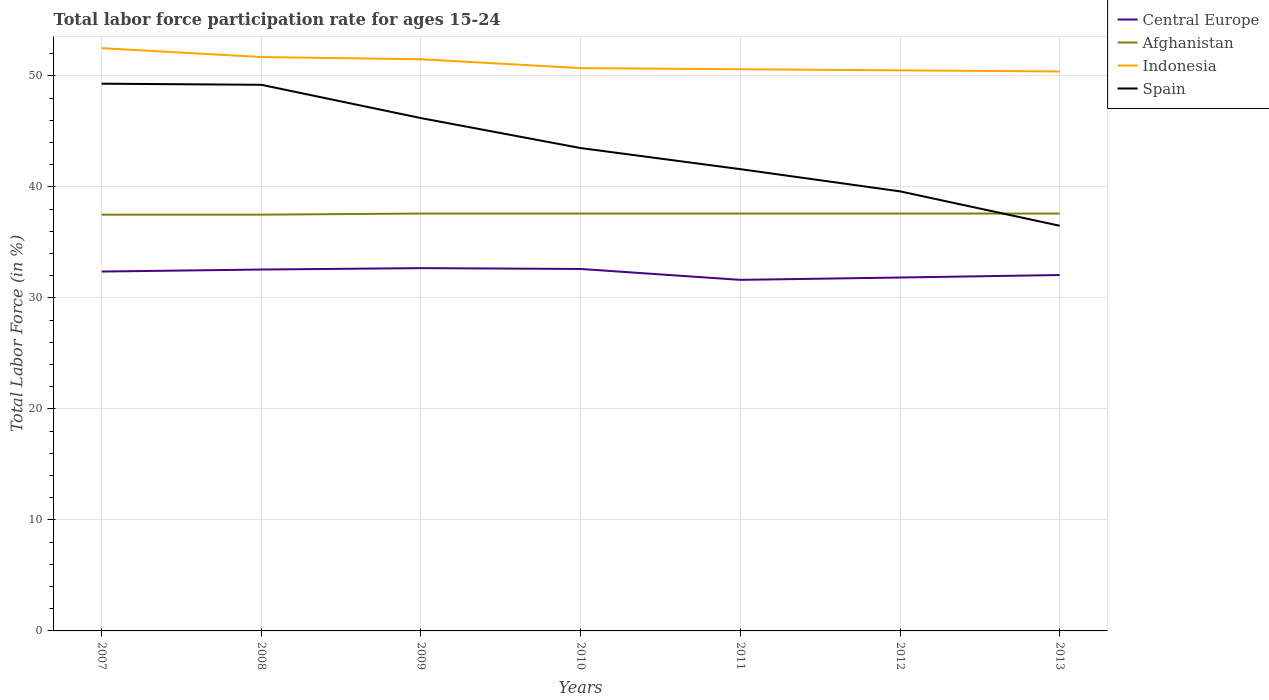How many different coloured lines are there?
Offer a terse response. 4. Does the line corresponding to Afghanistan intersect with the line corresponding to Spain?
Ensure brevity in your answer.  Yes. Is the number of lines equal to the number of legend labels?
Provide a succinct answer. Yes. Across all years, what is the maximum labor force participation rate in Afghanistan?
Offer a very short reply. 37.5. What is the total labor force participation rate in Spain in the graph?
Provide a short and direct response. 4.6. What is the difference between the highest and the second highest labor force participation rate in Afghanistan?
Ensure brevity in your answer.  0.1. What is the difference between the highest and the lowest labor force participation rate in Afghanistan?
Your answer should be very brief. 5. How many lines are there?
Offer a very short reply. 4. Where does the legend appear in the graph?
Provide a succinct answer. Top right. How are the legend labels stacked?
Offer a very short reply. Vertical. What is the title of the graph?
Offer a terse response. Total labor force participation rate for ages 15-24. Does "Antigua and Barbuda" appear as one of the legend labels in the graph?
Offer a terse response. No. What is the label or title of the X-axis?
Provide a short and direct response. Years. What is the label or title of the Y-axis?
Ensure brevity in your answer.  Total Labor Force (in %). What is the Total Labor Force (in %) of Central Europe in 2007?
Ensure brevity in your answer.  32.38. What is the Total Labor Force (in %) of Afghanistan in 2007?
Provide a succinct answer. 37.5. What is the Total Labor Force (in %) of Indonesia in 2007?
Your response must be concise. 52.5. What is the Total Labor Force (in %) of Spain in 2007?
Offer a terse response. 49.3. What is the Total Labor Force (in %) of Central Europe in 2008?
Give a very brief answer. 32.56. What is the Total Labor Force (in %) of Afghanistan in 2008?
Provide a succinct answer. 37.5. What is the Total Labor Force (in %) in Indonesia in 2008?
Make the answer very short. 51.7. What is the Total Labor Force (in %) of Spain in 2008?
Your answer should be very brief. 49.2. What is the Total Labor Force (in %) of Central Europe in 2009?
Provide a short and direct response. 32.68. What is the Total Labor Force (in %) of Afghanistan in 2009?
Provide a succinct answer. 37.6. What is the Total Labor Force (in %) in Indonesia in 2009?
Your answer should be very brief. 51.5. What is the Total Labor Force (in %) in Spain in 2009?
Provide a short and direct response. 46.2. What is the Total Labor Force (in %) in Central Europe in 2010?
Ensure brevity in your answer.  32.61. What is the Total Labor Force (in %) of Afghanistan in 2010?
Provide a short and direct response. 37.6. What is the Total Labor Force (in %) of Indonesia in 2010?
Give a very brief answer. 50.7. What is the Total Labor Force (in %) in Spain in 2010?
Your response must be concise. 43.5. What is the Total Labor Force (in %) in Central Europe in 2011?
Give a very brief answer. 31.63. What is the Total Labor Force (in %) of Afghanistan in 2011?
Provide a succinct answer. 37.6. What is the Total Labor Force (in %) in Indonesia in 2011?
Offer a very short reply. 50.6. What is the Total Labor Force (in %) of Spain in 2011?
Your response must be concise. 41.6. What is the Total Labor Force (in %) of Central Europe in 2012?
Ensure brevity in your answer.  31.84. What is the Total Labor Force (in %) of Afghanistan in 2012?
Your answer should be compact. 37.6. What is the Total Labor Force (in %) of Indonesia in 2012?
Provide a succinct answer. 50.5. What is the Total Labor Force (in %) of Spain in 2012?
Your response must be concise. 39.6. What is the Total Labor Force (in %) in Central Europe in 2013?
Give a very brief answer. 32.06. What is the Total Labor Force (in %) of Afghanistan in 2013?
Keep it short and to the point. 37.6. What is the Total Labor Force (in %) of Indonesia in 2013?
Keep it short and to the point. 50.4. What is the Total Labor Force (in %) of Spain in 2013?
Offer a terse response. 36.5. Across all years, what is the maximum Total Labor Force (in %) of Central Europe?
Provide a succinct answer. 32.68. Across all years, what is the maximum Total Labor Force (in %) of Afghanistan?
Offer a very short reply. 37.6. Across all years, what is the maximum Total Labor Force (in %) in Indonesia?
Give a very brief answer. 52.5. Across all years, what is the maximum Total Labor Force (in %) in Spain?
Your answer should be compact. 49.3. Across all years, what is the minimum Total Labor Force (in %) of Central Europe?
Your answer should be compact. 31.63. Across all years, what is the minimum Total Labor Force (in %) of Afghanistan?
Make the answer very short. 37.5. Across all years, what is the minimum Total Labor Force (in %) in Indonesia?
Ensure brevity in your answer.  50.4. Across all years, what is the minimum Total Labor Force (in %) of Spain?
Your answer should be compact. 36.5. What is the total Total Labor Force (in %) of Central Europe in the graph?
Your answer should be compact. 225.75. What is the total Total Labor Force (in %) in Afghanistan in the graph?
Ensure brevity in your answer.  263. What is the total Total Labor Force (in %) of Indonesia in the graph?
Provide a succinct answer. 357.9. What is the total Total Labor Force (in %) in Spain in the graph?
Offer a very short reply. 305.9. What is the difference between the Total Labor Force (in %) of Central Europe in 2007 and that in 2008?
Your response must be concise. -0.18. What is the difference between the Total Labor Force (in %) in Afghanistan in 2007 and that in 2008?
Provide a succinct answer. 0. What is the difference between the Total Labor Force (in %) of Spain in 2007 and that in 2008?
Keep it short and to the point. 0.1. What is the difference between the Total Labor Force (in %) in Central Europe in 2007 and that in 2009?
Give a very brief answer. -0.31. What is the difference between the Total Labor Force (in %) in Afghanistan in 2007 and that in 2009?
Keep it short and to the point. -0.1. What is the difference between the Total Labor Force (in %) in Central Europe in 2007 and that in 2010?
Your answer should be compact. -0.23. What is the difference between the Total Labor Force (in %) of Central Europe in 2007 and that in 2011?
Make the answer very short. 0.75. What is the difference between the Total Labor Force (in %) in Indonesia in 2007 and that in 2011?
Your answer should be very brief. 1.9. What is the difference between the Total Labor Force (in %) in Spain in 2007 and that in 2011?
Your answer should be compact. 7.7. What is the difference between the Total Labor Force (in %) of Central Europe in 2007 and that in 2012?
Your response must be concise. 0.54. What is the difference between the Total Labor Force (in %) of Afghanistan in 2007 and that in 2012?
Keep it short and to the point. -0.1. What is the difference between the Total Labor Force (in %) of Spain in 2007 and that in 2012?
Offer a terse response. 9.7. What is the difference between the Total Labor Force (in %) of Central Europe in 2007 and that in 2013?
Your answer should be compact. 0.31. What is the difference between the Total Labor Force (in %) of Indonesia in 2007 and that in 2013?
Ensure brevity in your answer.  2.1. What is the difference between the Total Labor Force (in %) in Spain in 2007 and that in 2013?
Provide a short and direct response. 12.8. What is the difference between the Total Labor Force (in %) of Central Europe in 2008 and that in 2009?
Provide a short and direct response. -0.13. What is the difference between the Total Labor Force (in %) of Indonesia in 2008 and that in 2009?
Ensure brevity in your answer.  0.2. What is the difference between the Total Labor Force (in %) of Central Europe in 2008 and that in 2010?
Your answer should be very brief. -0.05. What is the difference between the Total Labor Force (in %) of Afghanistan in 2008 and that in 2010?
Provide a short and direct response. -0.1. What is the difference between the Total Labor Force (in %) in Spain in 2008 and that in 2010?
Keep it short and to the point. 5.7. What is the difference between the Total Labor Force (in %) of Indonesia in 2008 and that in 2011?
Your answer should be very brief. 1.1. What is the difference between the Total Labor Force (in %) in Spain in 2008 and that in 2011?
Your answer should be very brief. 7.6. What is the difference between the Total Labor Force (in %) of Central Europe in 2008 and that in 2012?
Provide a succinct answer. 0.72. What is the difference between the Total Labor Force (in %) of Indonesia in 2008 and that in 2012?
Your answer should be compact. 1.2. What is the difference between the Total Labor Force (in %) of Central Europe in 2008 and that in 2013?
Make the answer very short. 0.5. What is the difference between the Total Labor Force (in %) of Afghanistan in 2008 and that in 2013?
Ensure brevity in your answer.  -0.1. What is the difference between the Total Labor Force (in %) of Indonesia in 2008 and that in 2013?
Offer a terse response. 1.3. What is the difference between the Total Labor Force (in %) in Central Europe in 2009 and that in 2010?
Offer a terse response. 0.08. What is the difference between the Total Labor Force (in %) of Afghanistan in 2009 and that in 2010?
Your response must be concise. 0. What is the difference between the Total Labor Force (in %) in Spain in 2009 and that in 2010?
Your answer should be compact. 2.7. What is the difference between the Total Labor Force (in %) in Central Europe in 2009 and that in 2011?
Provide a short and direct response. 1.06. What is the difference between the Total Labor Force (in %) of Indonesia in 2009 and that in 2011?
Provide a succinct answer. 0.9. What is the difference between the Total Labor Force (in %) of Spain in 2009 and that in 2011?
Provide a succinct answer. 4.6. What is the difference between the Total Labor Force (in %) in Central Europe in 2009 and that in 2012?
Your answer should be very brief. 0.85. What is the difference between the Total Labor Force (in %) of Afghanistan in 2009 and that in 2012?
Ensure brevity in your answer.  0. What is the difference between the Total Labor Force (in %) of Indonesia in 2009 and that in 2012?
Provide a short and direct response. 1. What is the difference between the Total Labor Force (in %) in Central Europe in 2009 and that in 2013?
Provide a short and direct response. 0.62. What is the difference between the Total Labor Force (in %) in Indonesia in 2009 and that in 2013?
Offer a terse response. 1.1. What is the difference between the Total Labor Force (in %) of Spain in 2009 and that in 2013?
Your response must be concise. 9.7. What is the difference between the Total Labor Force (in %) in Central Europe in 2010 and that in 2011?
Your answer should be very brief. 0.98. What is the difference between the Total Labor Force (in %) of Afghanistan in 2010 and that in 2011?
Keep it short and to the point. 0. What is the difference between the Total Labor Force (in %) in Indonesia in 2010 and that in 2011?
Provide a short and direct response. 0.1. What is the difference between the Total Labor Force (in %) of Spain in 2010 and that in 2011?
Your answer should be compact. 1.9. What is the difference between the Total Labor Force (in %) in Central Europe in 2010 and that in 2012?
Ensure brevity in your answer.  0.77. What is the difference between the Total Labor Force (in %) in Spain in 2010 and that in 2012?
Provide a succinct answer. 3.9. What is the difference between the Total Labor Force (in %) in Central Europe in 2010 and that in 2013?
Offer a very short reply. 0.55. What is the difference between the Total Labor Force (in %) in Afghanistan in 2010 and that in 2013?
Your response must be concise. 0. What is the difference between the Total Labor Force (in %) of Indonesia in 2010 and that in 2013?
Make the answer very short. 0.3. What is the difference between the Total Labor Force (in %) in Spain in 2010 and that in 2013?
Keep it short and to the point. 7. What is the difference between the Total Labor Force (in %) in Central Europe in 2011 and that in 2012?
Provide a succinct answer. -0.21. What is the difference between the Total Labor Force (in %) of Indonesia in 2011 and that in 2012?
Provide a short and direct response. 0.1. What is the difference between the Total Labor Force (in %) in Spain in 2011 and that in 2012?
Make the answer very short. 2. What is the difference between the Total Labor Force (in %) of Central Europe in 2011 and that in 2013?
Keep it short and to the point. -0.43. What is the difference between the Total Labor Force (in %) of Spain in 2011 and that in 2013?
Offer a terse response. 5.1. What is the difference between the Total Labor Force (in %) of Central Europe in 2012 and that in 2013?
Provide a short and direct response. -0.22. What is the difference between the Total Labor Force (in %) in Afghanistan in 2012 and that in 2013?
Give a very brief answer. 0. What is the difference between the Total Labor Force (in %) of Central Europe in 2007 and the Total Labor Force (in %) of Afghanistan in 2008?
Your answer should be very brief. -5.12. What is the difference between the Total Labor Force (in %) in Central Europe in 2007 and the Total Labor Force (in %) in Indonesia in 2008?
Offer a terse response. -19.32. What is the difference between the Total Labor Force (in %) in Central Europe in 2007 and the Total Labor Force (in %) in Spain in 2008?
Give a very brief answer. -16.82. What is the difference between the Total Labor Force (in %) in Afghanistan in 2007 and the Total Labor Force (in %) in Spain in 2008?
Ensure brevity in your answer.  -11.7. What is the difference between the Total Labor Force (in %) in Indonesia in 2007 and the Total Labor Force (in %) in Spain in 2008?
Offer a very short reply. 3.3. What is the difference between the Total Labor Force (in %) in Central Europe in 2007 and the Total Labor Force (in %) in Afghanistan in 2009?
Provide a succinct answer. -5.22. What is the difference between the Total Labor Force (in %) of Central Europe in 2007 and the Total Labor Force (in %) of Indonesia in 2009?
Your answer should be very brief. -19.12. What is the difference between the Total Labor Force (in %) in Central Europe in 2007 and the Total Labor Force (in %) in Spain in 2009?
Offer a very short reply. -13.82. What is the difference between the Total Labor Force (in %) of Central Europe in 2007 and the Total Labor Force (in %) of Afghanistan in 2010?
Provide a succinct answer. -5.22. What is the difference between the Total Labor Force (in %) in Central Europe in 2007 and the Total Labor Force (in %) in Indonesia in 2010?
Provide a short and direct response. -18.32. What is the difference between the Total Labor Force (in %) of Central Europe in 2007 and the Total Labor Force (in %) of Spain in 2010?
Offer a very short reply. -11.12. What is the difference between the Total Labor Force (in %) in Afghanistan in 2007 and the Total Labor Force (in %) in Indonesia in 2010?
Provide a short and direct response. -13.2. What is the difference between the Total Labor Force (in %) in Afghanistan in 2007 and the Total Labor Force (in %) in Spain in 2010?
Offer a terse response. -6. What is the difference between the Total Labor Force (in %) of Indonesia in 2007 and the Total Labor Force (in %) of Spain in 2010?
Provide a short and direct response. 9. What is the difference between the Total Labor Force (in %) of Central Europe in 2007 and the Total Labor Force (in %) of Afghanistan in 2011?
Ensure brevity in your answer.  -5.22. What is the difference between the Total Labor Force (in %) of Central Europe in 2007 and the Total Labor Force (in %) of Indonesia in 2011?
Give a very brief answer. -18.22. What is the difference between the Total Labor Force (in %) in Central Europe in 2007 and the Total Labor Force (in %) in Spain in 2011?
Offer a terse response. -9.22. What is the difference between the Total Labor Force (in %) in Afghanistan in 2007 and the Total Labor Force (in %) in Indonesia in 2011?
Your response must be concise. -13.1. What is the difference between the Total Labor Force (in %) in Central Europe in 2007 and the Total Labor Force (in %) in Afghanistan in 2012?
Your answer should be compact. -5.22. What is the difference between the Total Labor Force (in %) in Central Europe in 2007 and the Total Labor Force (in %) in Indonesia in 2012?
Provide a short and direct response. -18.12. What is the difference between the Total Labor Force (in %) in Central Europe in 2007 and the Total Labor Force (in %) in Spain in 2012?
Your answer should be compact. -7.22. What is the difference between the Total Labor Force (in %) of Afghanistan in 2007 and the Total Labor Force (in %) of Indonesia in 2012?
Provide a short and direct response. -13. What is the difference between the Total Labor Force (in %) of Afghanistan in 2007 and the Total Labor Force (in %) of Spain in 2012?
Provide a succinct answer. -2.1. What is the difference between the Total Labor Force (in %) in Indonesia in 2007 and the Total Labor Force (in %) in Spain in 2012?
Your response must be concise. 12.9. What is the difference between the Total Labor Force (in %) of Central Europe in 2007 and the Total Labor Force (in %) of Afghanistan in 2013?
Your answer should be compact. -5.22. What is the difference between the Total Labor Force (in %) in Central Europe in 2007 and the Total Labor Force (in %) in Indonesia in 2013?
Keep it short and to the point. -18.02. What is the difference between the Total Labor Force (in %) of Central Europe in 2007 and the Total Labor Force (in %) of Spain in 2013?
Your response must be concise. -4.12. What is the difference between the Total Labor Force (in %) in Afghanistan in 2007 and the Total Labor Force (in %) in Spain in 2013?
Provide a short and direct response. 1. What is the difference between the Total Labor Force (in %) in Indonesia in 2007 and the Total Labor Force (in %) in Spain in 2013?
Offer a terse response. 16. What is the difference between the Total Labor Force (in %) of Central Europe in 2008 and the Total Labor Force (in %) of Afghanistan in 2009?
Provide a succinct answer. -5.04. What is the difference between the Total Labor Force (in %) of Central Europe in 2008 and the Total Labor Force (in %) of Indonesia in 2009?
Keep it short and to the point. -18.94. What is the difference between the Total Labor Force (in %) of Central Europe in 2008 and the Total Labor Force (in %) of Spain in 2009?
Ensure brevity in your answer.  -13.64. What is the difference between the Total Labor Force (in %) of Afghanistan in 2008 and the Total Labor Force (in %) of Indonesia in 2009?
Make the answer very short. -14. What is the difference between the Total Labor Force (in %) of Afghanistan in 2008 and the Total Labor Force (in %) of Spain in 2009?
Make the answer very short. -8.7. What is the difference between the Total Labor Force (in %) of Indonesia in 2008 and the Total Labor Force (in %) of Spain in 2009?
Your answer should be compact. 5.5. What is the difference between the Total Labor Force (in %) of Central Europe in 2008 and the Total Labor Force (in %) of Afghanistan in 2010?
Keep it short and to the point. -5.04. What is the difference between the Total Labor Force (in %) in Central Europe in 2008 and the Total Labor Force (in %) in Indonesia in 2010?
Keep it short and to the point. -18.14. What is the difference between the Total Labor Force (in %) of Central Europe in 2008 and the Total Labor Force (in %) of Spain in 2010?
Offer a terse response. -10.94. What is the difference between the Total Labor Force (in %) in Afghanistan in 2008 and the Total Labor Force (in %) in Indonesia in 2010?
Provide a succinct answer. -13.2. What is the difference between the Total Labor Force (in %) of Central Europe in 2008 and the Total Labor Force (in %) of Afghanistan in 2011?
Provide a succinct answer. -5.04. What is the difference between the Total Labor Force (in %) in Central Europe in 2008 and the Total Labor Force (in %) in Indonesia in 2011?
Provide a short and direct response. -18.04. What is the difference between the Total Labor Force (in %) of Central Europe in 2008 and the Total Labor Force (in %) of Spain in 2011?
Provide a short and direct response. -9.04. What is the difference between the Total Labor Force (in %) in Afghanistan in 2008 and the Total Labor Force (in %) in Indonesia in 2011?
Offer a very short reply. -13.1. What is the difference between the Total Labor Force (in %) of Afghanistan in 2008 and the Total Labor Force (in %) of Spain in 2011?
Make the answer very short. -4.1. What is the difference between the Total Labor Force (in %) in Indonesia in 2008 and the Total Labor Force (in %) in Spain in 2011?
Provide a short and direct response. 10.1. What is the difference between the Total Labor Force (in %) in Central Europe in 2008 and the Total Labor Force (in %) in Afghanistan in 2012?
Keep it short and to the point. -5.04. What is the difference between the Total Labor Force (in %) of Central Europe in 2008 and the Total Labor Force (in %) of Indonesia in 2012?
Keep it short and to the point. -17.94. What is the difference between the Total Labor Force (in %) of Central Europe in 2008 and the Total Labor Force (in %) of Spain in 2012?
Provide a succinct answer. -7.04. What is the difference between the Total Labor Force (in %) of Afghanistan in 2008 and the Total Labor Force (in %) of Spain in 2012?
Make the answer very short. -2.1. What is the difference between the Total Labor Force (in %) of Indonesia in 2008 and the Total Labor Force (in %) of Spain in 2012?
Give a very brief answer. 12.1. What is the difference between the Total Labor Force (in %) in Central Europe in 2008 and the Total Labor Force (in %) in Afghanistan in 2013?
Your response must be concise. -5.04. What is the difference between the Total Labor Force (in %) in Central Europe in 2008 and the Total Labor Force (in %) in Indonesia in 2013?
Ensure brevity in your answer.  -17.84. What is the difference between the Total Labor Force (in %) of Central Europe in 2008 and the Total Labor Force (in %) of Spain in 2013?
Make the answer very short. -3.94. What is the difference between the Total Labor Force (in %) in Afghanistan in 2008 and the Total Labor Force (in %) in Spain in 2013?
Offer a terse response. 1. What is the difference between the Total Labor Force (in %) of Central Europe in 2009 and the Total Labor Force (in %) of Afghanistan in 2010?
Provide a short and direct response. -4.92. What is the difference between the Total Labor Force (in %) of Central Europe in 2009 and the Total Labor Force (in %) of Indonesia in 2010?
Your answer should be very brief. -18.02. What is the difference between the Total Labor Force (in %) of Central Europe in 2009 and the Total Labor Force (in %) of Spain in 2010?
Make the answer very short. -10.82. What is the difference between the Total Labor Force (in %) of Afghanistan in 2009 and the Total Labor Force (in %) of Indonesia in 2010?
Keep it short and to the point. -13.1. What is the difference between the Total Labor Force (in %) in Central Europe in 2009 and the Total Labor Force (in %) in Afghanistan in 2011?
Ensure brevity in your answer.  -4.92. What is the difference between the Total Labor Force (in %) in Central Europe in 2009 and the Total Labor Force (in %) in Indonesia in 2011?
Give a very brief answer. -17.92. What is the difference between the Total Labor Force (in %) of Central Europe in 2009 and the Total Labor Force (in %) of Spain in 2011?
Make the answer very short. -8.92. What is the difference between the Total Labor Force (in %) of Afghanistan in 2009 and the Total Labor Force (in %) of Indonesia in 2011?
Keep it short and to the point. -13. What is the difference between the Total Labor Force (in %) in Afghanistan in 2009 and the Total Labor Force (in %) in Spain in 2011?
Ensure brevity in your answer.  -4. What is the difference between the Total Labor Force (in %) in Central Europe in 2009 and the Total Labor Force (in %) in Afghanistan in 2012?
Make the answer very short. -4.92. What is the difference between the Total Labor Force (in %) of Central Europe in 2009 and the Total Labor Force (in %) of Indonesia in 2012?
Provide a short and direct response. -17.82. What is the difference between the Total Labor Force (in %) of Central Europe in 2009 and the Total Labor Force (in %) of Spain in 2012?
Provide a succinct answer. -6.92. What is the difference between the Total Labor Force (in %) of Afghanistan in 2009 and the Total Labor Force (in %) of Spain in 2012?
Provide a short and direct response. -2. What is the difference between the Total Labor Force (in %) of Central Europe in 2009 and the Total Labor Force (in %) of Afghanistan in 2013?
Your answer should be very brief. -4.92. What is the difference between the Total Labor Force (in %) of Central Europe in 2009 and the Total Labor Force (in %) of Indonesia in 2013?
Offer a terse response. -17.72. What is the difference between the Total Labor Force (in %) in Central Europe in 2009 and the Total Labor Force (in %) in Spain in 2013?
Your answer should be very brief. -3.82. What is the difference between the Total Labor Force (in %) of Afghanistan in 2009 and the Total Labor Force (in %) of Indonesia in 2013?
Make the answer very short. -12.8. What is the difference between the Total Labor Force (in %) in Afghanistan in 2009 and the Total Labor Force (in %) in Spain in 2013?
Your answer should be very brief. 1.1. What is the difference between the Total Labor Force (in %) in Indonesia in 2009 and the Total Labor Force (in %) in Spain in 2013?
Provide a succinct answer. 15. What is the difference between the Total Labor Force (in %) in Central Europe in 2010 and the Total Labor Force (in %) in Afghanistan in 2011?
Your answer should be compact. -4.99. What is the difference between the Total Labor Force (in %) in Central Europe in 2010 and the Total Labor Force (in %) in Indonesia in 2011?
Offer a very short reply. -17.99. What is the difference between the Total Labor Force (in %) of Central Europe in 2010 and the Total Labor Force (in %) of Spain in 2011?
Your answer should be compact. -8.99. What is the difference between the Total Labor Force (in %) of Afghanistan in 2010 and the Total Labor Force (in %) of Indonesia in 2011?
Provide a succinct answer. -13. What is the difference between the Total Labor Force (in %) in Afghanistan in 2010 and the Total Labor Force (in %) in Spain in 2011?
Offer a terse response. -4. What is the difference between the Total Labor Force (in %) of Central Europe in 2010 and the Total Labor Force (in %) of Afghanistan in 2012?
Provide a succinct answer. -4.99. What is the difference between the Total Labor Force (in %) of Central Europe in 2010 and the Total Labor Force (in %) of Indonesia in 2012?
Offer a very short reply. -17.89. What is the difference between the Total Labor Force (in %) of Central Europe in 2010 and the Total Labor Force (in %) of Spain in 2012?
Your response must be concise. -6.99. What is the difference between the Total Labor Force (in %) in Afghanistan in 2010 and the Total Labor Force (in %) in Indonesia in 2012?
Provide a succinct answer. -12.9. What is the difference between the Total Labor Force (in %) in Afghanistan in 2010 and the Total Labor Force (in %) in Spain in 2012?
Offer a terse response. -2. What is the difference between the Total Labor Force (in %) of Indonesia in 2010 and the Total Labor Force (in %) of Spain in 2012?
Offer a very short reply. 11.1. What is the difference between the Total Labor Force (in %) in Central Europe in 2010 and the Total Labor Force (in %) in Afghanistan in 2013?
Your answer should be very brief. -4.99. What is the difference between the Total Labor Force (in %) of Central Europe in 2010 and the Total Labor Force (in %) of Indonesia in 2013?
Ensure brevity in your answer.  -17.79. What is the difference between the Total Labor Force (in %) in Central Europe in 2010 and the Total Labor Force (in %) in Spain in 2013?
Offer a very short reply. -3.89. What is the difference between the Total Labor Force (in %) of Afghanistan in 2010 and the Total Labor Force (in %) of Indonesia in 2013?
Ensure brevity in your answer.  -12.8. What is the difference between the Total Labor Force (in %) in Central Europe in 2011 and the Total Labor Force (in %) in Afghanistan in 2012?
Offer a terse response. -5.97. What is the difference between the Total Labor Force (in %) of Central Europe in 2011 and the Total Labor Force (in %) of Indonesia in 2012?
Your answer should be compact. -18.87. What is the difference between the Total Labor Force (in %) in Central Europe in 2011 and the Total Labor Force (in %) in Spain in 2012?
Keep it short and to the point. -7.97. What is the difference between the Total Labor Force (in %) in Afghanistan in 2011 and the Total Labor Force (in %) in Indonesia in 2012?
Ensure brevity in your answer.  -12.9. What is the difference between the Total Labor Force (in %) of Central Europe in 2011 and the Total Labor Force (in %) of Afghanistan in 2013?
Your response must be concise. -5.97. What is the difference between the Total Labor Force (in %) of Central Europe in 2011 and the Total Labor Force (in %) of Indonesia in 2013?
Give a very brief answer. -18.77. What is the difference between the Total Labor Force (in %) in Central Europe in 2011 and the Total Labor Force (in %) in Spain in 2013?
Your answer should be very brief. -4.87. What is the difference between the Total Labor Force (in %) of Indonesia in 2011 and the Total Labor Force (in %) of Spain in 2013?
Provide a short and direct response. 14.1. What is the difference between the Total Labor Force (in %) of Central Europe in 2012 and the Total Labor Force (in %) of Afghanistan in 2013?
Give a very brief answer. -5.76. What is the difference between the Total Labor Force (in %) of Central Europe in 2012 and the Total Labor Force (in %) of Indonesia in 2013?
Your answer should be very brief. -18.56. What is the difference between the Total Labor Force (in %) in Central Europe in 2012 and the Total Labor Force (in %) in Spain in 2013?
Give a very brief answer. -4.66. What is the difference between the Total Labor Force (in %) in Afghanistan in 2012 and the Total Labor Force (in %) in Spain in 2013?
Make the answer very short. 1.1. What is the difference between the Total Labor Force (in %) of Indonesia in 2012 and the Total Labor Force (in %) of Spain in 2013?
Your answer should be compact. 14. What is the average Total Labor Force (in %) in Central Europe per year?
Keep it short and to the point. 32.25. What is the average Total Labor Force (in %) in Afghanistan per year?
Your answer should be very brief. 37.57. What is the average Total Labor Force (in %) of Indonesia per year?
Your answer should be very brief. 51.13. What is the average Total Labor Force (in %) of Spain per year?
Give a very brief answer. 43.7. In the year 2007, what is the difference between the Total Labor Force (in %) in Central Europe and Total Labor Force (in %) in Afghanistan?
Ensure brevity in your answer.  -5.12. In the year 2007, what is the difference between the Total Labor Force (in %) in Central Europe and Total Labor Force (in %) in Indonesia?
Provide a succinct answer. -20.12. In the year 2007, what is the difference between the Total Labor Force (in %) of Central Europe and Total Labor Force (in %) of Spain?
Provide a short and direct response. -16.92. In the year 2007, what is the difference between the Total Labor Force (in %) of Indonesia and Total Labor Force (in %) of Spain?
Keep it short and to the point. 3.2. In the year 2008, what is the difference between the Total Labor Force (in %) in Central Europe and Total Labor Force (in %) in Afghanistan?
Offer a terse response. -4.94. In the year 2008, what is the difference between the Total Labor Force (in %) of Central Europe and Total Labor Force (in %) of Indonesia?
Provide a succinct answer. -19.14. In the year 2008, what is the difference between the Total Labor Force (in %) in Central Europe and Total Labor Force (in %) in Spain?
Keep it short and to the point. -16.64. In the year 2009, what is the difference between the Total Labor Force (in %) in Central Europe and Total Labor Force (in %) in Afghanistan?
Your answer should be compact. -4.92. In the year 2009, what is the difference between the Total Labor Force (in %) in Central Europe and Total Labor Force (in %) in Indonesia?
Your response must be concise. -18.82. In the year 2009, what is the difference between the Total Labor Force (in %) of Central Europe and Total Labor Force (in %) of Spain?
Provide a short and direct response. -13.52. In the year 2010, what is the difference between the Total Labor Force (in %) in Central Europe and Total Labor Force (in %) in Afghanistan?
Provide a short and direct response. -4.99. In the year 2010, what is the difference between the Total Labor Force (in %) in Central Europe and Total Labor Force (in %) in Indonesia?
Ensure brevity in your answer.  -18.09. In the year 2010, what is the difference between the Total Labor Force (in %) of Central Europe and Total Labor Force (in %) of Spain?
Make the answer very short. -10.89. In the year 2010, what is the difference between the Total Labor Force (in %) in Afghanistan and Total Labor Force (in %) in Indonesia?
Ensure brevity in your answer.  -13.1. In the year 2011, what is the difference between the Total Labor Force (in %) of Central Europe and Total Labor Force (in %) of Afghanistan?
Provide a succinct answer. -5.97. In the year 2011, what is the difference between the Total Labor Force (in %) of Central Europe and Total Labor Force (in %) of Indonesia?
Provide a short and direct response. -18.97. In the year 2011, what is the difference between the Total Labor Force (in %) of Central Europe and Total Labor Force (in %) of Spain?
Provide a short and direct response. -9.97. In the year 2011, what is the difference between the Total Labor Force (in %) in Afghanistan and Total Labor Force (in %) in Indonesia?
Your answer should be compact. -13. In the year 2012, what is the difference between the Total Labor Force (in %) of Central Europe and Total Labor Force (in %) of Afghanistan?
Your answer should be compact. -5.76. In the year 2012, what is the difference between the Total Labor Force (in %) of Central Europe and Total Labor Force (in %) of Indonesia?
Offer a terse response. -18.66. In the year 2012, what is the difference between the Total Labor Force (in %) of Central Europe and Total Labor Force (in %) of Spain?
Offer a very short reply. -7.76. In the year 2012, what is the difference between the Total Labor Force (in %) of Indonesia and Total Labor Force (in %) of Spain?
Your response must be concise. 10.9. In the year 2013, what is the difference between the Total Labor Force (in %) of Central Europe and Total Labor Force (in %) of Afghanistan?
Offer a very short reply. -5.54. In the year 2013, what is the difference between the Total Labor Force (in %) in Central Europe and Total Labor Force (in %) in Indonesia?
Provide a succinct answer. -18.34. In the year 2013, what is the difference between the Total Labor Force (in %) of Central Europe and Total Labor Force (in %) of Spain?
Ensure brevity in your answer.  -4.44. In the year 2013, what is the difference between the Total Labor Force (in %) of Afghanistan and Total Labor Force (in %) of Indonesia?
Ensure brevity in your answer.  -12.8. In the year 2013, what is the difference between the Total Labor Force (in %) of Afghanistan and Total Labor Force (in %) of Spain?
Keep it short and to the point. 1.1. What is the ratio of the Total Labor Force (in %) of Central Europe in 2007 to that in 2008?
Keep it short and to the point. 0.99. What is the ratio of the Total Labor Force (in %) in Indonesia in 2007 to that in 2008?
Keep it short and to the point. 1.02. What is the ratio of the Total Labor Force (in %) of Central Europe in 2007 to that in 2009?
Provide a succinct answer. 0.99. What is the ratio of the Total Labor Force (in %) in Indonesia in 2007 to that in 2009?
Offer a terse response. 1.02. What is the ratio of the Total Labor Force (in %) of Spain in 2007 to that in 2009?
Provide a succinct answer. 1.07. What is the ratio of the Total Labor Force (in %) of Afghanistan in 2007 to that in 2010?
Your response must be concise. 1. What is the ratio of the Total Labor Force (in %) of Indonesia in 2007 to that in 2010?
Your answer should be very brief. 1.04. What is the ratio of the Total Labor Force (in %) in Spain in 2007 to that in 2010?
Offer a very short reply. 1.13. What is the ratio of the Total Labor Force (in %) of Central Europe in 2007 to that in 2011?
Make the answer very short. 1.02. What is the ratio of the Total Labor Force (in %) of Indonesia in 2007 to that in 2011?
Provide a short and direct response. 1.04. What is the ratio of the Total Labor Force (in %) in Spain in 2007 to that in 2011?
Offer a terse response. 1.19. What is the ratio of the Total Labor Force (in %) in Central Europe in 2007 to that in 2012?
Give a very brief answer. 1.02. What is the ratio of the Total Labor Force (in %) of Afghanistan in 2007 to that in 2012?
Provide a succinct answer. 1. What is the ratio of the Total Labor Force (in %) of Indonesia in 2007 to that in 2012?
Provide a succinct answer. 1.04. What is the ratio of the Total Labor Force (in %) of Spain in 2007 to that in 2012?
Keep it short and to the point. 1.24. What is the ratio of the Total Labor Force (in %) of Central Europe in 2007 to that in 2013?
Give a very brief answer. 1.01. What is the ratio of the Total Labor Force (in %) in Afghanistan in 2007 to that in 2013?
Your answer should be very brief. 1. What is the ratio of the Total Labor Force (in %) in Indonesia in 2007 to that in 2013?
Make the answer very short. 1.04. What is the ratio of the Total Labor Force (in %) in Spain in 2007 to that in 2013?
Give a very brief answer. 1.35. What is the ratio of the Total Labor Force (in %) in Central Europe in 2008 to that in 2009?
Make the answer very short. 1. What is the ratio of the Total Labor Force (in %) in Spain in 2008 to that in 2009?
Keep it short and to the point. 1.06. What is the ratio of the Total Labor Force (in %) of Afghanistan in 2008 to that in 2010?
Offer a very short reply. 1. What is the ratio of the Total Labor Force (in %) of Indonesia in 2008 to that in 2010?
Provide a short and direct response. 1.02. What is the ratio of the Total Labor Force (in %) of Spain in 2008 to that in 2010?
Your answer should be compact. 1.13. What is the ratio of the Total Labor Force (in %) of Central Europe in 2008 to that in 2011?
Offer a terse response. 1.03. What is the ratio of the Total Labor Force (in %) in Afghanistan in 2008 to that in 2011?
Ensure brevity in your answer.  1. What is the ratio of the Total Labor Force (in %) in Indonesia in 2008 to that in 2011?
Your answer should be compact. 1.02. What is the ratio of the Total Labor Force (in %) in Spain in 2008 to that in 2011?
Offer a very short reply. 1.18. What is the ratio of the Total Labor Force (in %) of Central Europe in 2008 to that in 2012?
Keep it short and to the point. 1.02. What is the ratio of the Total Labor Force (in %) in Indonesia in 2008 to that in 2012?
Your response must be concise. 1.02. What is the ratio of the Total Labor Force (in %) of Spain in 2008 to that in 2012?
Your answer should be very brief. 1.24. What is the ratio of the Total Labor Force (in %) of Central Europe in 2008 to that in 2013?
Your response must be concise. 1.02. What is the ratio of the Total Labor Force (in %) in Indonesia in 2008 to that in 2013?
Provide a succinct answer. 1.03. What is the ratio of the Total Labor Force (in %) of Spain in 2008 to that in 2013?
Your response must be concise. 1.35. What is the ratio of the Total Labor Force (in %) of Central Europe in 2009 to that in 2010?
Your answer should be compact. 1. What is the ratio of the Total Labor Force (in %) in Indonesia in 2009 to that in 2010?
Provide a succinct answer. 1.02. What is the ratio of the Total Labor Force (in %) of Spain in 2009 to that in 2010?
Your answer should be very brief. 1.06. What is the ratio of the Total Labor Force (in %) of Central Europe in 2009 to that in 2011?
Keep it short and to the point. 1.03. What is the ratio of the Total Labor Force (in %) in Indonesia in 2009 to that in 2011?
Your answer should be compact. 1.02. What is the ratio of the Total Labor Force (in %) of Spain in 2009 to that in 2011?
Provide a short and direct response. 1.11. What is the ratio of the Total Labor Force (in %) in Central Europe in 2009 to that in 2012?
Offer a terse response. 1.03. What is the ratio of the Total Labor Force (in %) of Afghanistan in 2009 to that in 2012?
Ensure brevity in your answer.  1. What is the ratio of the Total Labor Force (in %) of Indonesia in 2009 to that in 2012?
Provide a short and direct response. 1.02. What is the ratio of the Total Labor Force (in %) in Spain in 2009 to that in 2012?
Provide a short and direct response. 1.17. What is the ratio of the Total Labor Force (in %) in Central Europe in 2009 to that in 2013?
Offer a terse response. 1.02. What is the ratio of the Total Labor Force (in %) in Afghanistan in 2009 to that in 2013?
Provide a succinct answer. 1. What is the ratio of the Total Labor Force (in %) in Indonesia in 2009 to that in 2013?
Provide a succinct answer. 1.02. What is the ratio of the Total Labor Force (in %) of Spain in 2009 to that in 2013?
Offer a very short reply. 1.27. What is the ratio of the Total Labor Force (in %) of Central Europe in 2010 to that in 2011?
Provide a short and direct response. 1.03. What is the ratio of the Total Labor Force (in %) in Spain in 2010 to that in 2011?
Make the answer very short. 1.05. What is the ratio of the Total Labor Force (in %) in Central Europe in 2010 to that in 2012?
Offer a very short reply. 1.02. What is the ratio of the Total Labor Force (in %) in Indonesia in 2010 to that in 2012?
Provide a short and direct response. 1. What is the ratio of the Total Labor Force (in %) in Spain in 2010 to that in 2012?
Offer a very short reply. 1.1. What is the ratio of the Total Labor Force (in %) of Spain in 2010 to that in 2013?
Keep it short and to the point. 1.19. What is the ratio of the Total Labor Force (in %) in Afghanistan in 2011 to that in 2012?
Ensure brevity in your answer.  1. What is the ratio of the Total Labor Force (in %) in Indonesia in 2011 to that in 2012?
Offer a very short reply. 1. What is the ratio of the Total Labor Force (in %) in Spain in 2011 to that in 2012?
Provide a succinct answer. 1.05. What is the ratio of the Total Labor Force (in %) of Central Europe in 2011 to that in 2013?
Offer a terse response. 0.99. What is the ratio of the Total Labor Force (in %) in Afghanistan in 2011 to that in 2013?
Offer a terse response. 1. What is the ratio of the Total Labor Force (in %) of Spain in 2011 to that in 2013?
Offer a terse response. 1.14. What is the ratio of the Total Labor Force (in %) of Central Europe in 2012 to that in 2013?
Your answer should be very brief. 0.99. What is the ratio of the Total Labor Force (in %) in Afghanistan in 2012 to that in 2013?
Provide a short and direct response. 1. What is the ratio of the Total Labor Force (in %) in Indonesia in 2012 to that in 2013?
Provide a succinct answer. 1. What is the ratio of the Total Labor Force (in %) of Spain in 2012 to that in 2013?
Provide a succinct answer. 1.08. What is the difference between the highest and the second highest Total Labor Force (in %) in Central Europe?
Offer a terse response. 0.08. What is the difference between the highest and the second highest Total Labor Force (in %) of Afghanistan?
Ensure brevity in your answer.  0. What is the difference between the highest and the second highest Total Labor Force (in %) in Spain?
Your response must be concise. 0.1. What is the difference between the highest and the lowest Total Labor Force (in %) of Central Europe?
Give a very brief answer. 1.06. What is the difference between the highest and the lowest Total Labor Force (in %) in Indonesia?
Offer a very short reply. 2.1. 